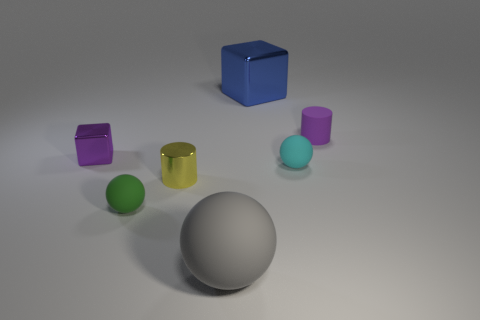What is the large thing that is behind the cylinder right of the tiny shiny thing that is in front of the small shiny cube made of?
Provide a succinct answer. Metal. There is a sphere that is on the left side of the big blue metallic thing and on the right side of the tiny yellow cylinder; what is its size?
Keep it short and to the point. Large. What number of cylinders are either large gray things or tiny purple matte things?
Your answer should be compact. 1. There is a shiny cylinder that is the same size as the purple shiny thing; what color is it?
Your response must be concise. Yellow. Is there any other thing that is the same shape as the big rubber thing?
Provide a succinct answer. Yes. The other big object that is the same shape as the purple metal thing is what color?
Keep it short and to the point. Blue. What number of things are either balls or big things in front of the blue shiny cube?
Offer a very short reply. 3. Are there fewer tiny green things that are left of the tiny purple metallic object than small shiny cubes?
Provide a succinct answer. Yes. There is a metal block behind the purple thing that is right of the small rubber sphere left of the large blue thing; how big is it?
Make the answer very short. Large. What color is the rubber ball that is to the right of the tiny yellow cylinder and left of the cyan object?
Give a very brief answer. Gray. 